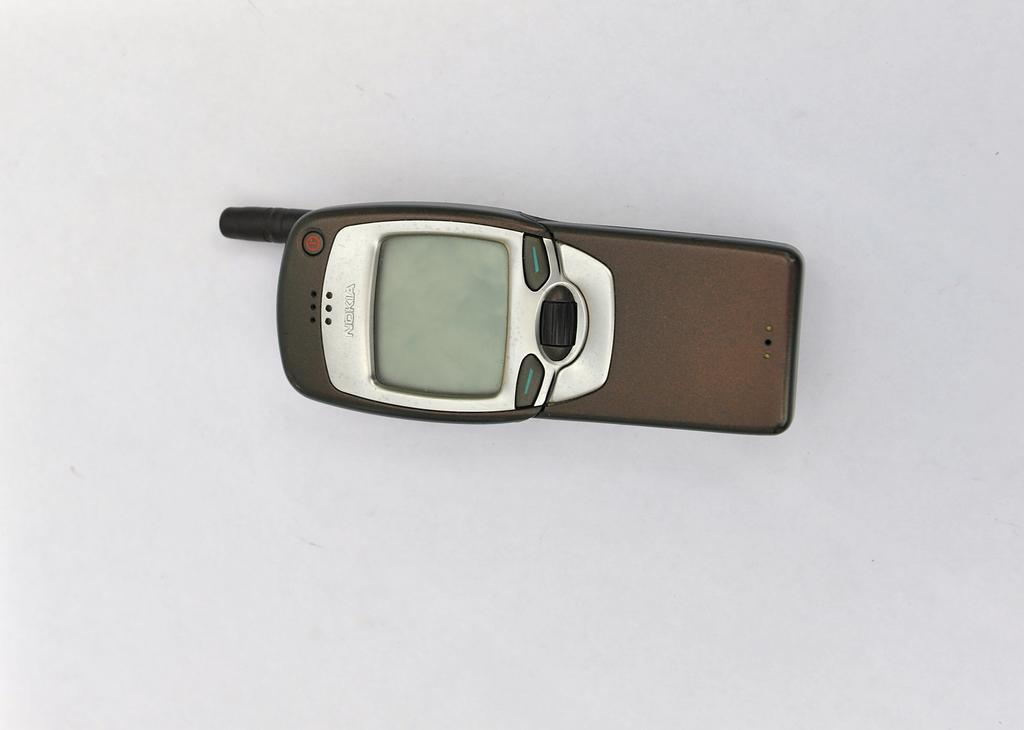<image>
Share a concise interpretation of the image provided. a Nokia phone that is brown in color 